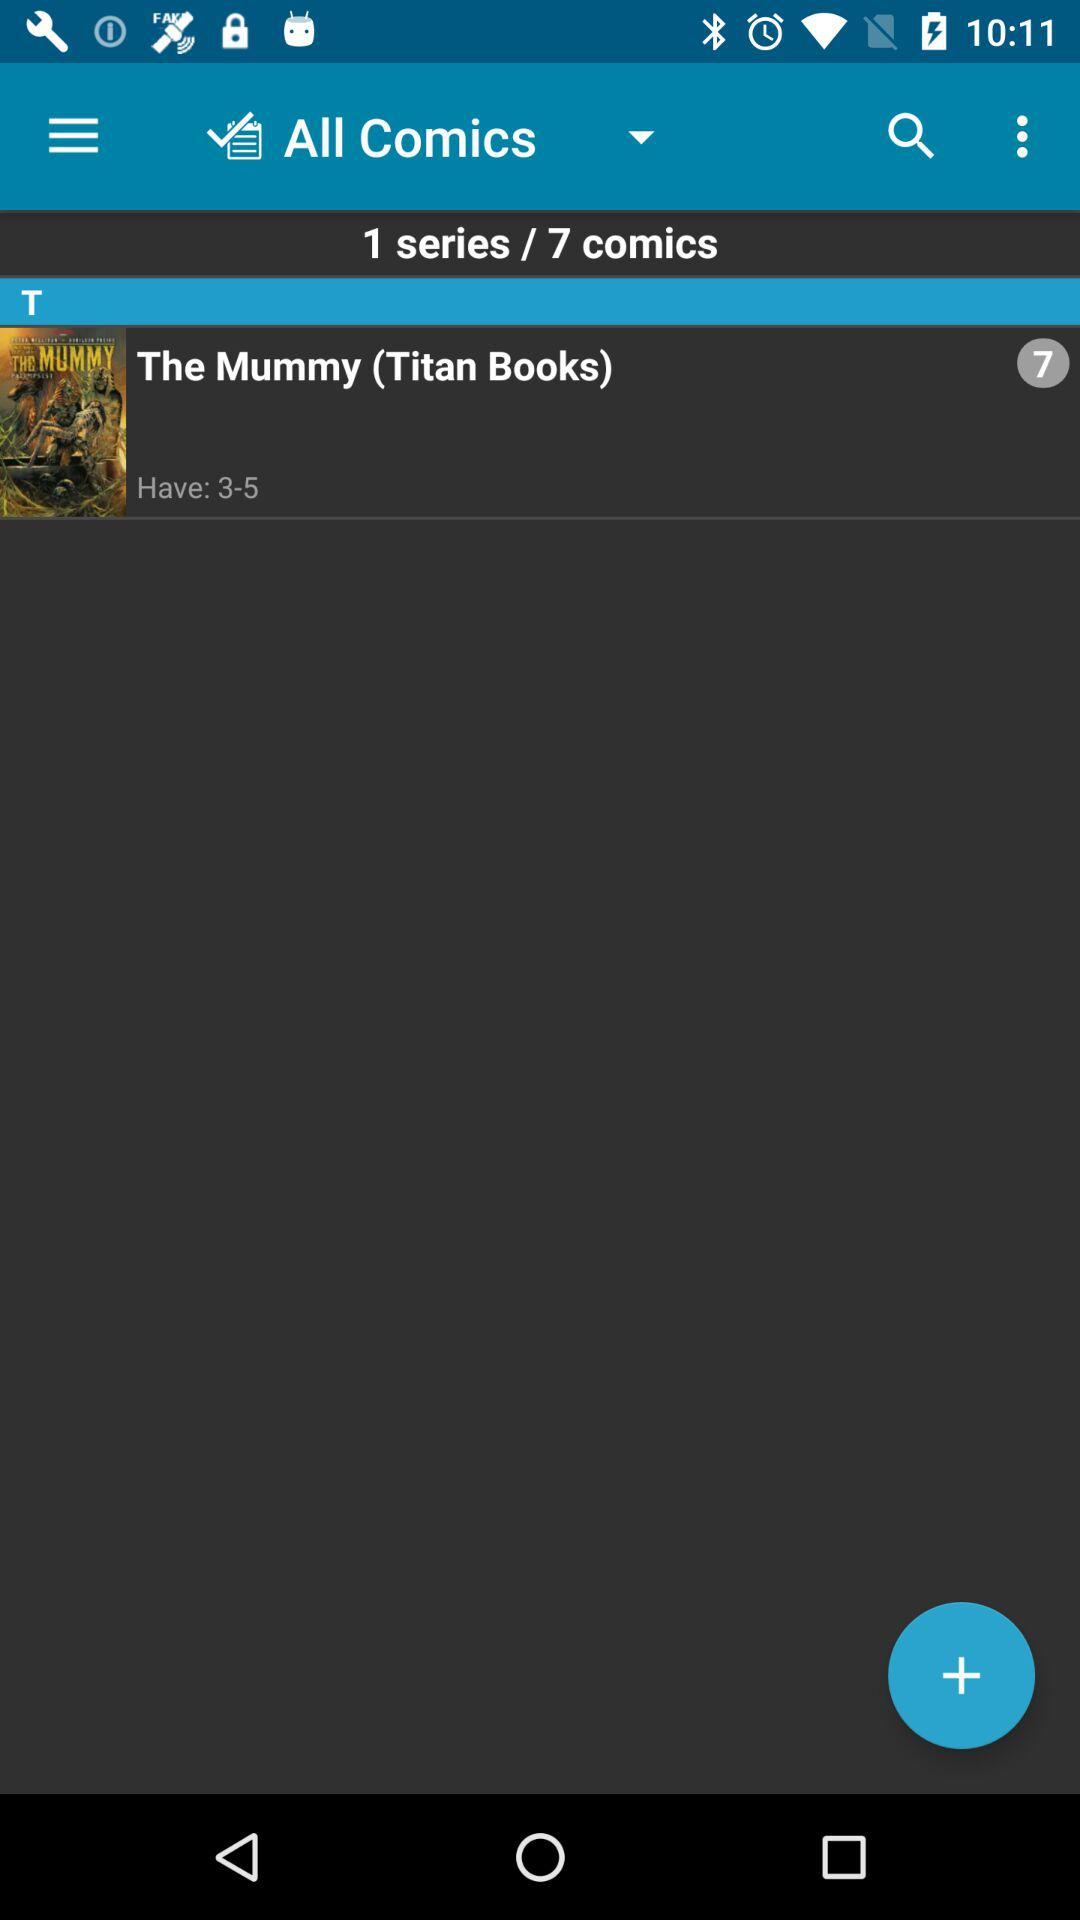What is the name of the comic book series shown there? The name of the comic book series shown there is "The Mummy". 